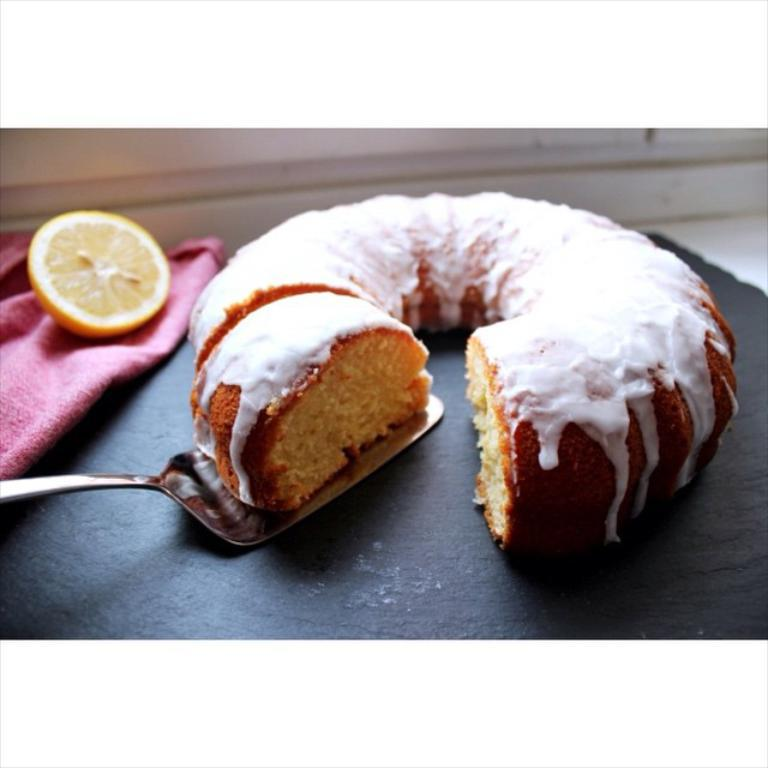What type of food can be seen in the image? There is food in the image, with white and brown colors. What other object is present in the image, besides the food? There is a lemon in the image. Can you describe the lemon's location in the image? The lemon is on a pink cloth. What utensil is visible in the image? There is a spoon in the image. What type of cast can be seen on the bed in the image? There is no cast or bed present in the image; it only features food, a lemon, a pink cloth, and a spoon. 